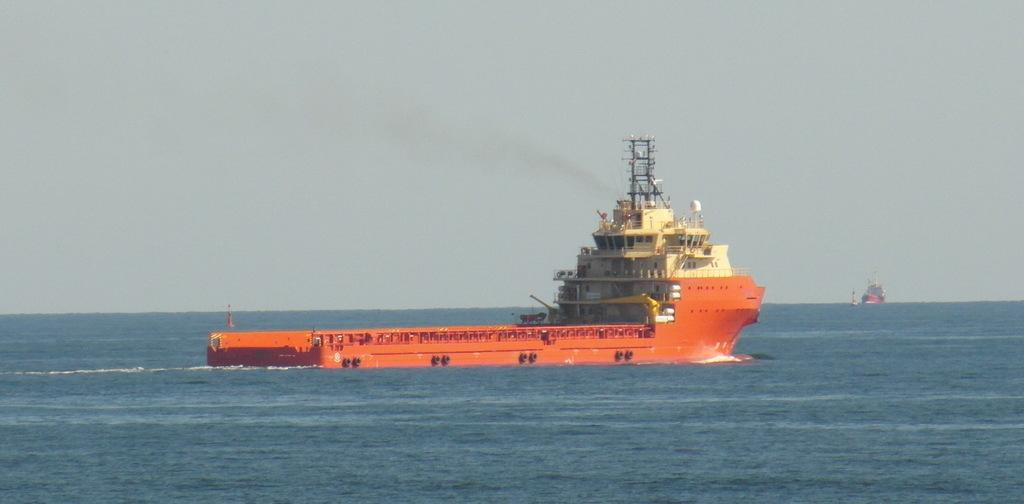What is the main subject of the image? The main subject of the image is a ship on the surface of the water. Can you describe the background of the image? In the background of the image, there is another ship visible. How many ships are present in the image? There are two ships present in the image. What type of tent can be seen on the chin of the ship in the image? There is no tent present on the chin of the ship in the image, as ships do not have chins. 